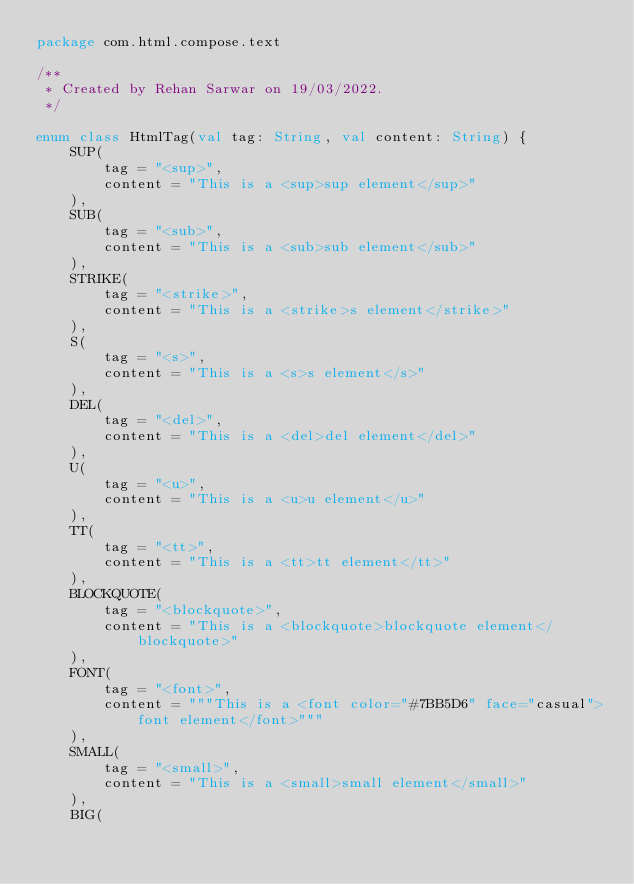Convert code to text. <code><loc_0><loc_0><loc_500><loc_500><_Kotlin_>package com.html.compose.text

/**
 * Created by Rehan Sarwar on 19/03/2022.
 */

enum class HtmlTag(val tag: String, val content: String) {
    SUP(
        tag = "<sup>",
        content = "This is a <sup>sup element</sup>"
    ),
    SUB(
        tag = "<sub>",
        content = "This is a <sub>sub element</sub>"
    ),
    STRIKE(
        tag = "<strike>",
        content = "This is a <strike>s element</strike>"
    ),
    S(
        tag = "<s>",
        content = "This is a <s>s element</s>"
    ),
    DEL(
        tag = "<del>",
        content = "This is a <del>del element</del>"
    ),
    U(
        tag = "<u>",
        content = "This is a <u>u element</u>"
    ),
    TT(
        tag = "<tt>",
        content = "This is a <tt>tt element</tt>"
    ),
    BLOCKQUOTE(
        tag = "<blockquote>",
        content = "This is a <blockquote>blockquote element</blockquote>"
    ),
    FONT(
        tag = "<font>",
        content = """This is a <font color="#7BB5D6" face="casual">font element</font>"""
    ),
    SMALL(
        tag = "<small>",
        content = "This is a <small>small element</small>"
    ),
    BIG(</code> 